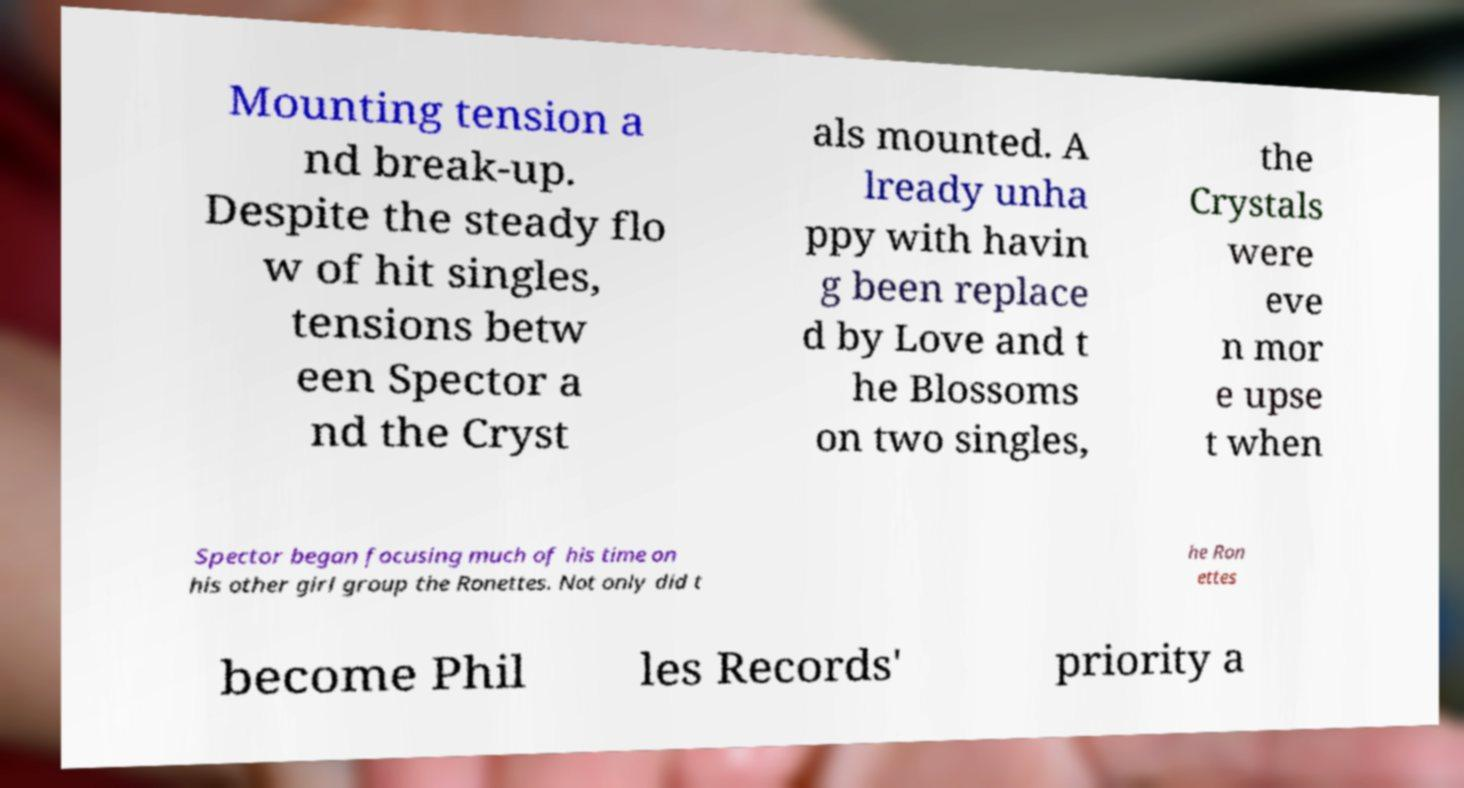Please read and relay the text visible in this image. What does it say? Mounting tension a nd break-up. Despite the steady flo w of hit singles, tensions betw een Spector a nd the Cryst als mounted. A lready unha ppy with havin g been replace d by Love and t he Blossoms on two singles, the Crystals were eve n mor e upse t when Spector began focusing much of his time on his other girl group the Ronettes. Not only did t he Ron ettes become Phil les Records' priority a 